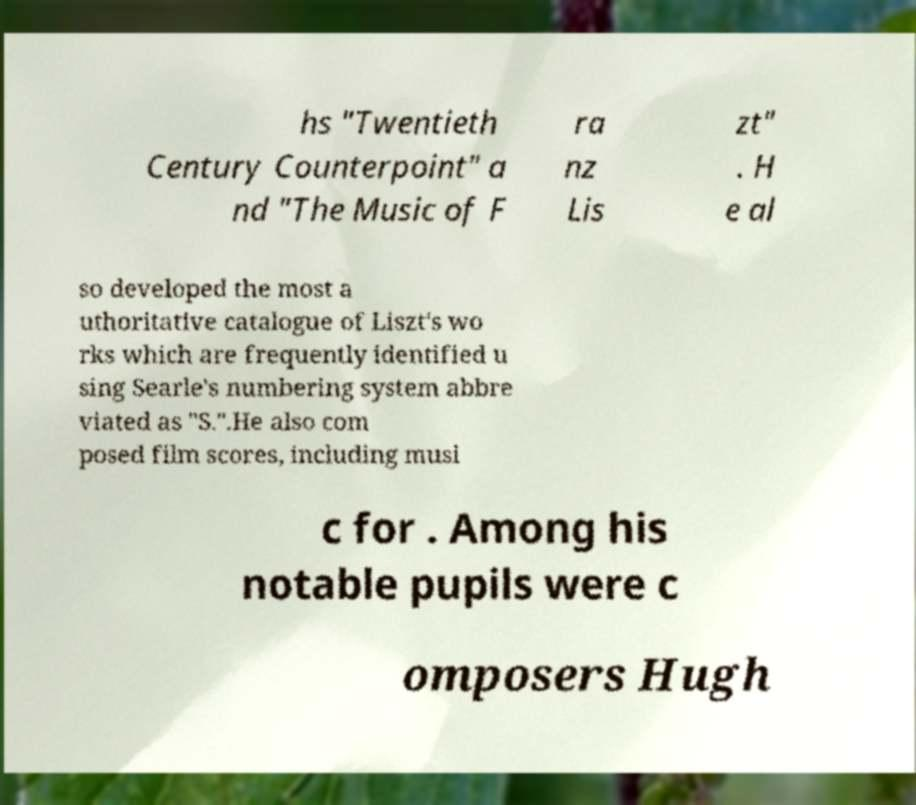Can you accurately transcribe the text from the provided image for me? hs "Twentieth Century Counterpoint" a nd "The Music of F ra nz Lis zt" . H e al so developed the most a uthoritative catalogue of Liszt's wo rks which are frequently identified u sing Searle's numbering system abbre viated as "S.".He also com posed film scores, including musi c for . Among his notable pupils were c omposers Hugh 